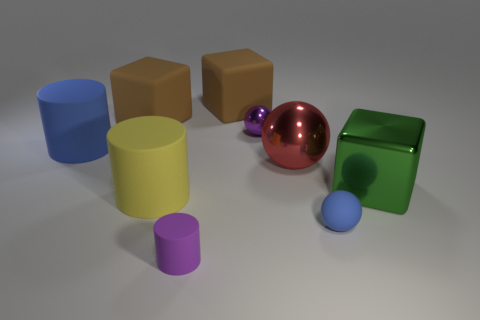Subtract all cubes. How many objects are left? 6 Add 2 large things. How many large things exist? 8 Subtract 1 purple spheres. How many objects are left? 8 Subtract all big brown matte cubes. Subtract all matte spheres. How many objects are left? 6 Add 8 rubber blocks. How many rubber blocks are left? 10 